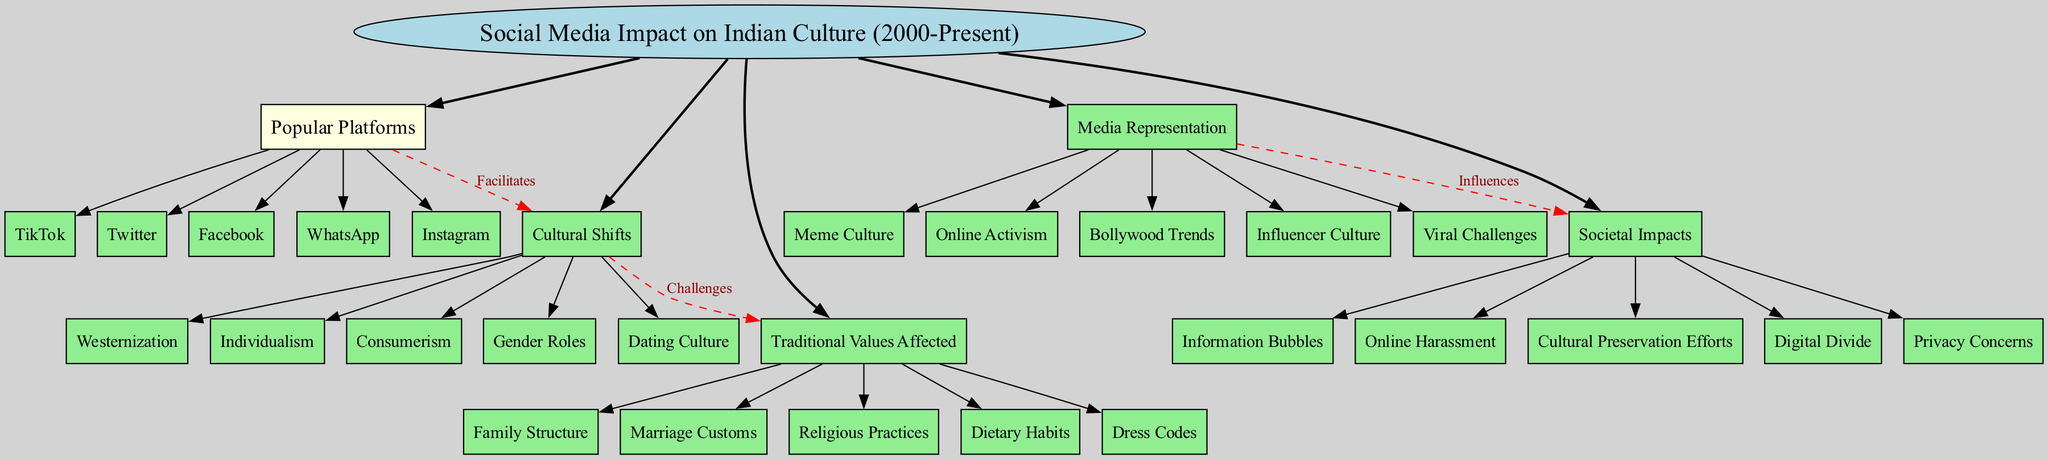What is the central topic of the diagram? The diagram's central topic is explicitly labeled as "Social Media Impact on Indian Culture (2000-Present)", which is the main focus of the mind map.
Answer: Social Media Impact on Indian Culture (2000-Present) How many main branches are there? The diagram includes five main branches stemming from the central topic, which can be counted visually.
Answer: 5 Which platform is connected to "Cultural Shifts"? The connection from "Popular Platforms" to "Cultural Shifts" indicates that all identified platforms, including Facebook, WhatsApp, Instagram, TikTok, and Twitter, facilitate cultural shifts. However, the specific name of the platform can vary, but it starts with "Facebook".
Answer: Facebook What are the traditional values affected by social media? By reviewing the "Traditional Values Affected" branch, we can identify five values listed: Family Structure, Marriage Customs, Religious Practices, Dietary Habits, and Dress Codes.
Answer: Family Structure, Marriage Customs, Religious Practices, Dietary Habits, Dress Codes Which cultural shift challenges traditional values? The second connection in the diagram shows that "Cultural Shifts" are perceived as challenges to "Traditional Values Affected", specifically indicating that various changes like Westernization, Individualism, and Consumerism pose challenges.
Answer: Westernization What influences societal impacts according to the diagram? The "Media Representation" branch has a direct influence on various "Societal Impacts", as indicated by the connection label "Influences".
Answer: Media Representation Which cultural shift corresponds to dating culture? "Dating Culture" is one of the sub-branches listed under the "Cultural Shifts", indicating a specific cultural change influenced by social media platforms.
Answer: Dating Culture How does "Influencer Culture" relate to societal impacts? The relationship established in the "Media Representation" branch indicates that "Influencer Culture" impacts societal aspects, influenced by the trends showcased via social media.
Answer: Influences Which traditional value is affected by online harassment? The connection inferred from the "Societal Impacts" illustrates the effects of online harassment on traditional values, though the specific traditional value might not be directly stated, it can be understood as all listed traditional values being at risk.
Answer: All traditional values (implied) What type of diagram is represented here? The structure of the diagram used is a mind map, which displays relationships and connections among different subjects relating to social media's impact on culture.
Answer: Mind Map 